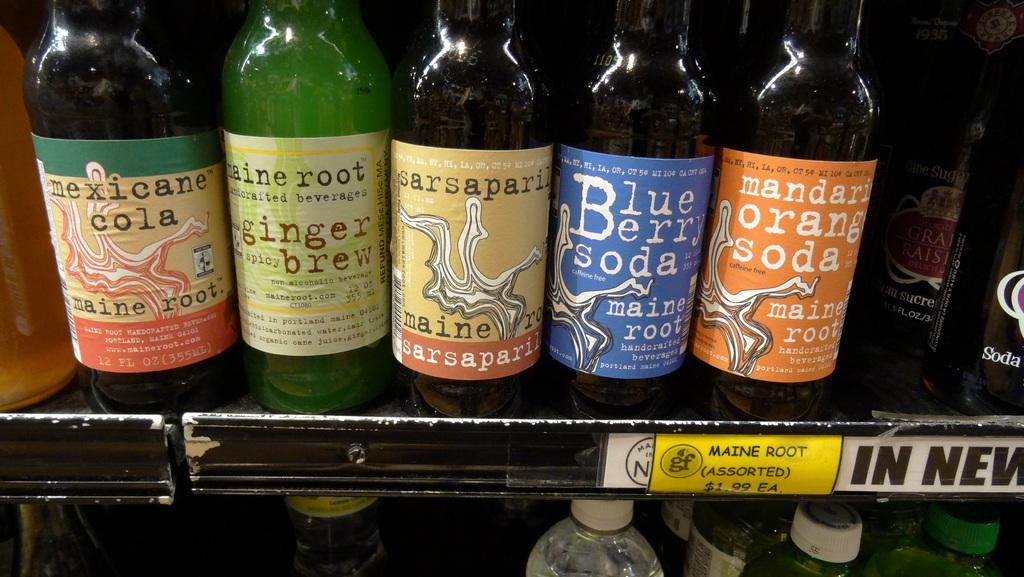<image>
Render a clear and concise summary of the photo. Five bottles of soda, one of which is mandarin orange. 